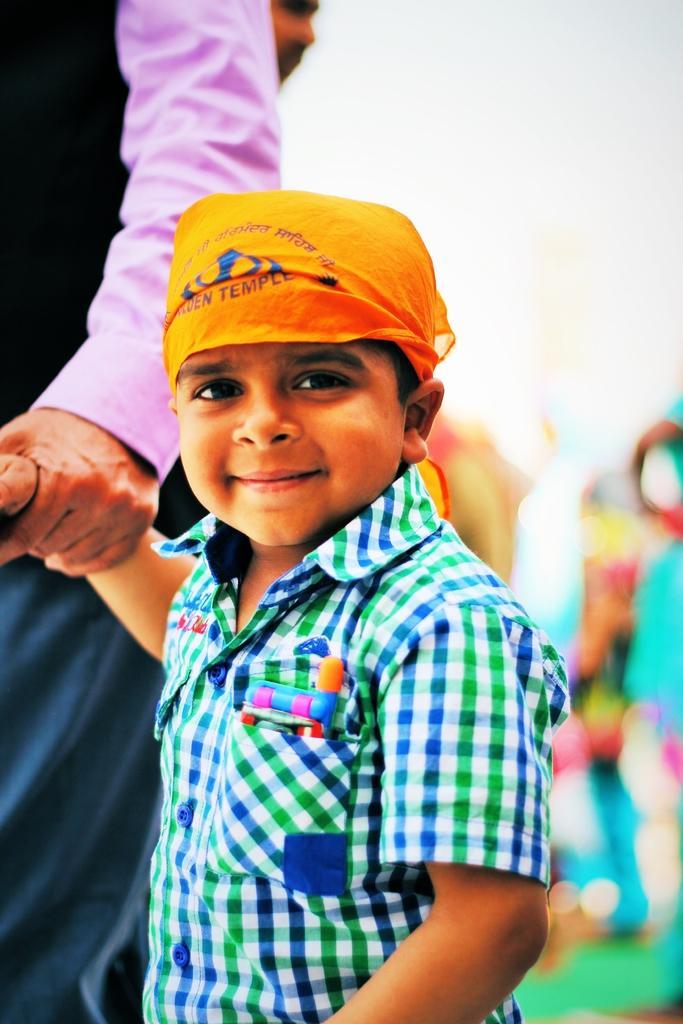Can you describe this image briefly? In this picture there is a small boy wearing green color shirt and orange cloth on the forehead, standing in the front smiling and giving a pose into the camera. Behind there is a man wearing pink color shirt is holding the boy hand. Behind there is a blur background. 